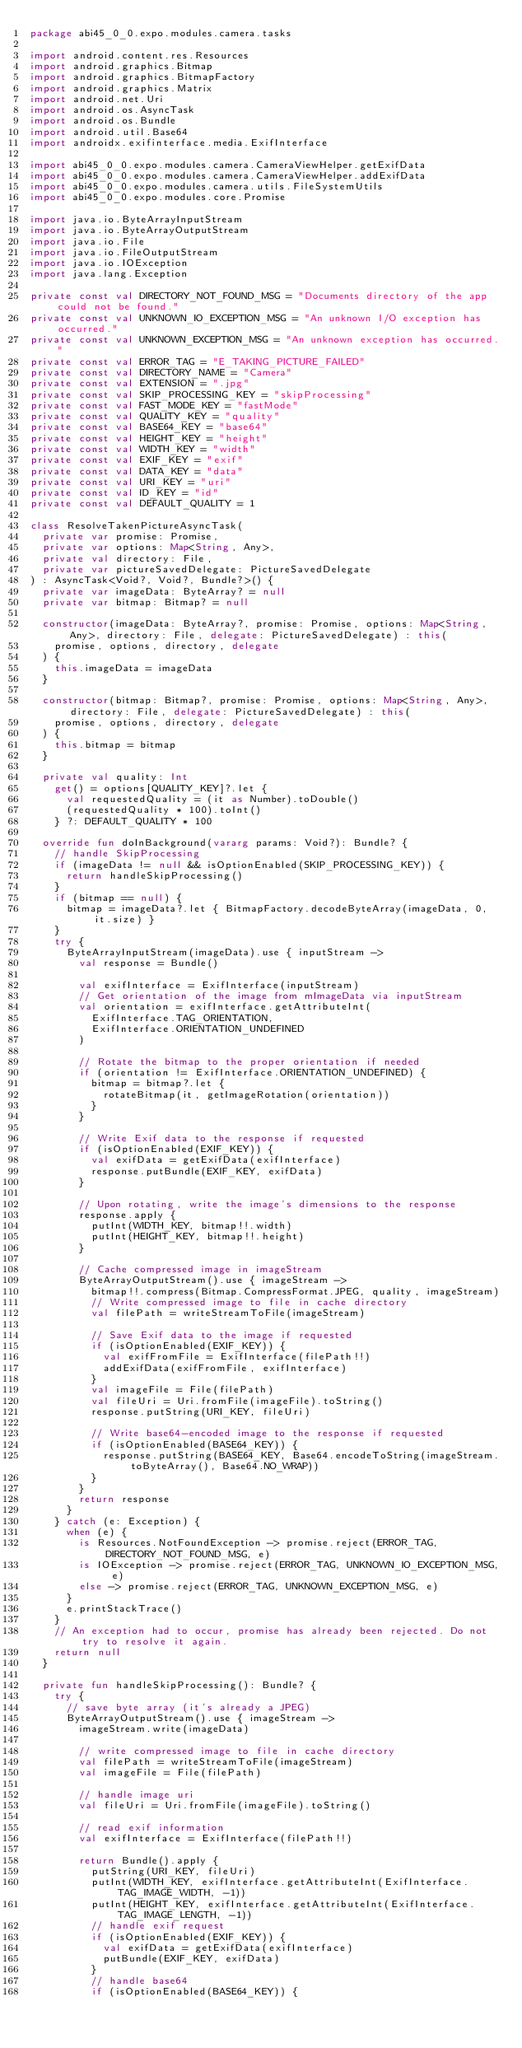<code> <loc_0><loc_0><loc_500><loc_500><_Kotlin_>package abi45_0_0.expo.modules.camera.tasks

import android.content.res.Resources
import android.graphics.Bitmap
import android.graphics.BitmapFactory
import android.graphics.Matrix
import android.net.Uri
import android.os.AsyncTask
import android.os.Bundle
import android.util.Base64
import androidx.exifinterface.media.ExifInterface

import abi45_0_0.expo.modules.camera.CameraViewHelper.getExifData
import abi45_0_0.expo.modules.camera.CameraViewHelper.addExifData
import abi45_0_0.expo.modules.camera.utils.FileSystemUtils
import abi45_0_0.expo.modules.core.Promise

import java.io.ByteArrayInputStream
import java.io.ByteArrayOutputStream
import java.io.File
import java.io.FileOutputStream
import java.io.IOException
import java.lang.Exception

private const val DIRECTORY_NOT_FOUND_MSG = "Documents directory of the app could not be found."
private const val UNKNOWN_IO_EXCEPTION_MSG = "An unknown I/O exception has occurred."
private const val UNKNOWN_EXCEPTION_MSG = "An unknown exception has occurred."
private const val ERROR_TAG = "E_TAKING_PICTURE_FAILED"
private const val DIRECTORY_NAME = "Camera"
private const val EXTENSION = ".jpg"
private const val SKIP_PROCESSING_KEY = "skipProcessing"
private const val FAST_MODE_KEY = "fastMode"
private const val QUALITY_KEY = "quality"
private const val BASE64_KEY = "base64"
private const val HEIGHT_KEY = "height"
private const val WIDTH_KEY = "width"
private const val EXIF_KEY = "exif"
private const val DATA_KEY = "data"
private const val URI_KEY = "uri"
private const val ID_KEY = "id"
private const val DEFAULT_QUALITY = 1

class ResolveTakenPictureAsyncTask(
  private var promise: Promise,
  private var options: Map<String, Any>,
  private val directory: File,
  private var pictureSavedDelegate: PictureSavedDelegate
) : AsyncTask<Void?, Void?, Bundle?>() {
  private var imageData: ByteArray? = null
  private var bitmap: Bitmap? = null

  constructor(imageData: ByteArray?, promise: Promise, options: Map<String, Any>, directory: File, delegate: PictureSavedDelegate) : this(
    promise, options, directory, delegate
  ) {
    this.imageData = imageData
  }

  constructor(bitmap: Bitmap?, promise: Promise, options: Map<String, Any>, directory: File, delegate: PictureSavedDelegate) : this(
    promise, options, directory, delegate
  ) {
    this.bitmap = bitmap
  }

  private val quality: Int
    get() = options[QUALITY_KEY]?.let {
      val requestedQuality = (it as Number).toDouble()
      (requestedQuality * 100).toInt()
    } ?: DEFAULT_QUALITY * 100

  override fun doInBackground(vararg params: Void?): Bundle? {
    // handle SkipProcessing
    if (imageData != null && isOptionEnabled(SKIP_PROCESSING_KEY)) {
      return handleSkipProcessing()
    }
    if (bitmap == null) {
      bitmap = imageData?.let { BitmapFactory.decodeByteArray(imageData, 0, it.size) }
    }
    try {
      ByteArrayInputStream(imageData).use { inputStream ->
        val response = Bundle()

        val exifInterface = ExifInterface(inputStream)
        // Get orientation of the image from mImageData via inputStream
        val orientation = exifInterface.getAttributeInt(
          ExifInterface.TAG_ORIENTATION,
          ExifInterface.ORIENTATION_UNDEFINED
        )

        // Rotate the bitmap to the proper orientation if needed
        if (orientation != ExifInterface.ORIENTATION_UNDEFINED) {
          bitmap = bitmap?.let {
            rotateBitmap(it, getImageRotation(orientation))
          }
        }

        // Write Exif data to the response if requested
        if (isOptionEnabled(EXIF_KEY)) {
          val exifData = getExifData(exifInterface)
          response.putBundle(EXIF_KEY, exifData)
        }

        // Upon rotating, write the image's dimensions to the response
        response.apply {
          putInt(WIDTH_KEY, bitmap!!.width)
          putInt(HEIGHT_KEY, bitmap!!.height)
        }

        // Cache compressed image in imageStream
        ByteArrayOutputStream().use { imageStream ->
          bitmap!!.compress(Bitmap.CompressFormat.JPEG, quality, imageStream)
          // Write compressed image to file in cache directory
          val filePath = writeStreamToFile(imageStream)

          // Save Exif data to the image if requested
          if (isOptionEnabled(EXIF_KEY)) {
            val exifFromFile = ExifInterface(filePath!!)
            addExifData(exifFromFile, exifInterface)
          }
          val imageFile = File(filePath)
          val fileUri = Uri.fromFile(imageFile).toString()
          response.putString(URI_KEY, fileUri)

          // Write base64-encoded image to the response if requested
          if (isOptionEnabled(BASE64_KEY)) {
            response.putString(BASE64_KEY, Base64.encodeToString(imageStream.toByteArray(), Base64.NO_WRAP))
          }
        }
        return response
      }
    } catch (e: Exception) {
      when (e) {
        is Resources.NotFoundException -> promise.reject(ERROR_TAG, DIRECTORY_NOT_FOUND_MSG, e)
        is IOException -> promise.reject(ERROR_TAG, UNKNOWN_IO_EXCEPTION_MSG, e)
        else -> promise.reject(ERROR_TAG, UNKNOWN_EXCEPTION_MSG, e)
      }
      e.printStackTrace()
    }
    // An exception had to occur, promise has already been rejected. Do not try to resolve it again.
    return null
  }

  private fun handleSkipProcessing(): Bundle? {
    try {
      // save byte array (it's already a JPEG)
      ByteArrayOutputStream().use { imageStream ->
        imageStream.write(imageData)

        // write compressed image to file in cache directory
        val filePath = writeStreamToFile(imageStream)
        val imageFile = File(filePath)

        // handle image uri
        val fileUri = Uri.fromFile(imageFile).toString()

        // read exif information
        val exifInterface = ExifInterface(filePath!!)

        return Bundle().apply {
          putString(URI_KEY, fileUri)
          putInt(WIDTH_KEY, exifInterface.getAttributeInt(ExifInterface.TAG_IMAGE_WIDTH, -1))
          putInt(HEIGHT_KEY, exifInterface.getAttributeInt(ExifInterface.TAG_IMAGE_LENGTH, -1))
          // handle exif request
          if (isOptionEnabled(EXIF_KEY)) {
            val exifData = getExifData(exifInterface)
            putBundle(EXIF_KEY, exifData)
          }
          // handle base64
          if (isOptionEnabled(BASE64_KEY)) {</code> 